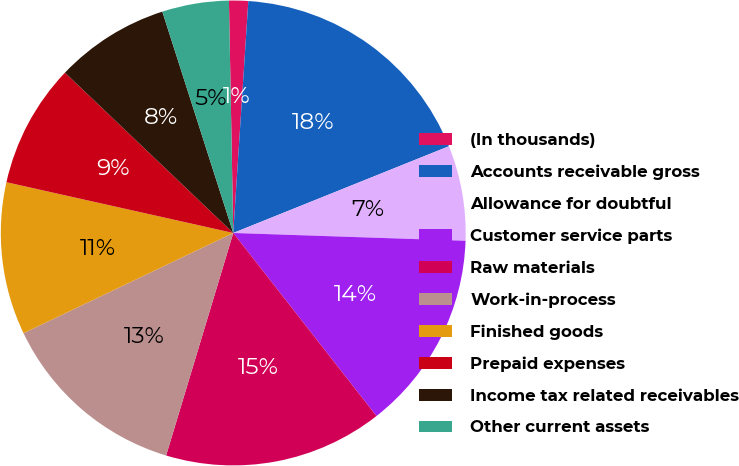<chart> <loc_0><loc_0><loc_500><loc_500><pie_chart><fcel>(In thousands)<fcel>Accounts receivable gross<fcel>Allowance for doubtful<fcel>Customer service parts<fcel>Raw materials<fcel>Work-in-process<fcel>Finished goods<fcel>Prepaid expenses<fcel>Income tax related receivables<fcel>Other current assets<nl><fcel>1.33%<fcel>17.88%<fcel>6.62%<fcel>13.9%<fcel>15.23%<fcel>13.24%<fcel>10.6%<fcel>8.61%<fcel>7.95%<fcel>4.64%<nl></chart> 